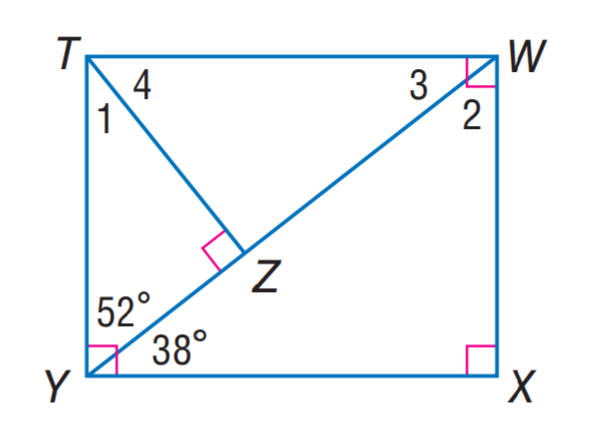Answer the mathemtical geometry problem and directly provide the correct option letter.
Question: Find m \angle 2.
Choices: A: 28 B: 38 C: 52 D: 62 C 